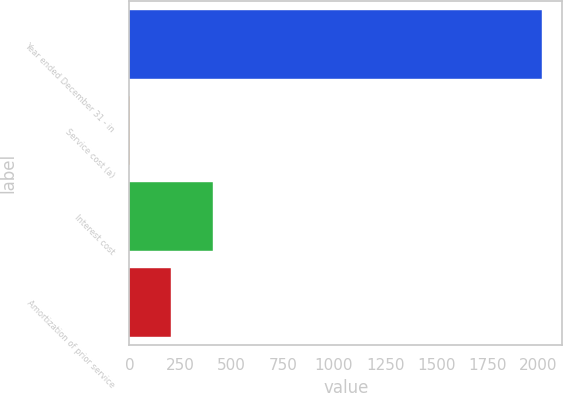Convert chart to OTSL. <chart><loc_0><loc_0><loc_500><loc_500><bar_chart><fcel>Year ended December 31 - in<fcel>Service cost (a)<fcel>Interest cost<fcel>Amortization of prior service<nl><fcel>2015<fcel>5<fcel>407<fcel>206<nl></chart> 